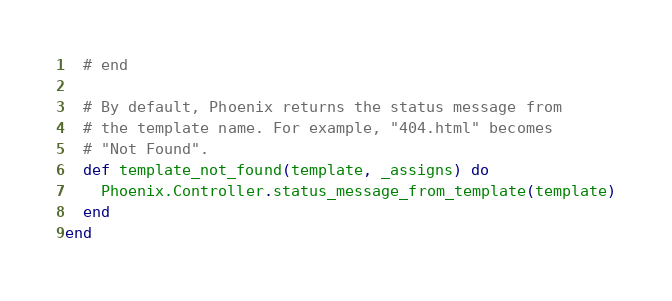<code> <loc_0><loc_0><loc_500><loc_500><_Elixir_>  # end

  # By default, Phoenix returns the status message from
  # the template name. For example, "404.html" becomes
  # "Not Found".
  def template_not_found(template, _assigns) do
    Phoenix.Controller.status_message_from_template(template)
  end
end
</code> 